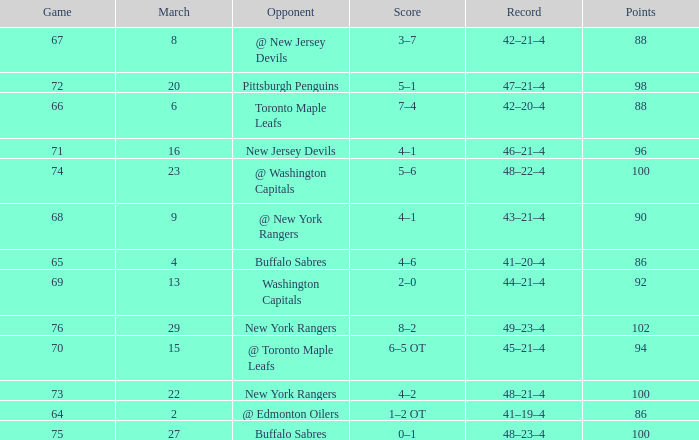Which Points have a Record of 45–21–4, and a Game larger than 70? None. 